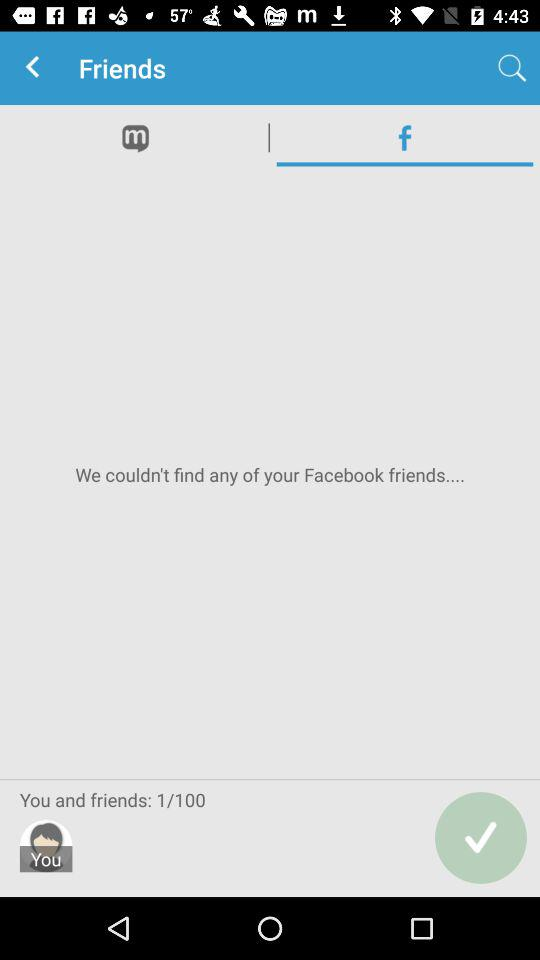Which tab is selected? The selected tab is "facebook". 